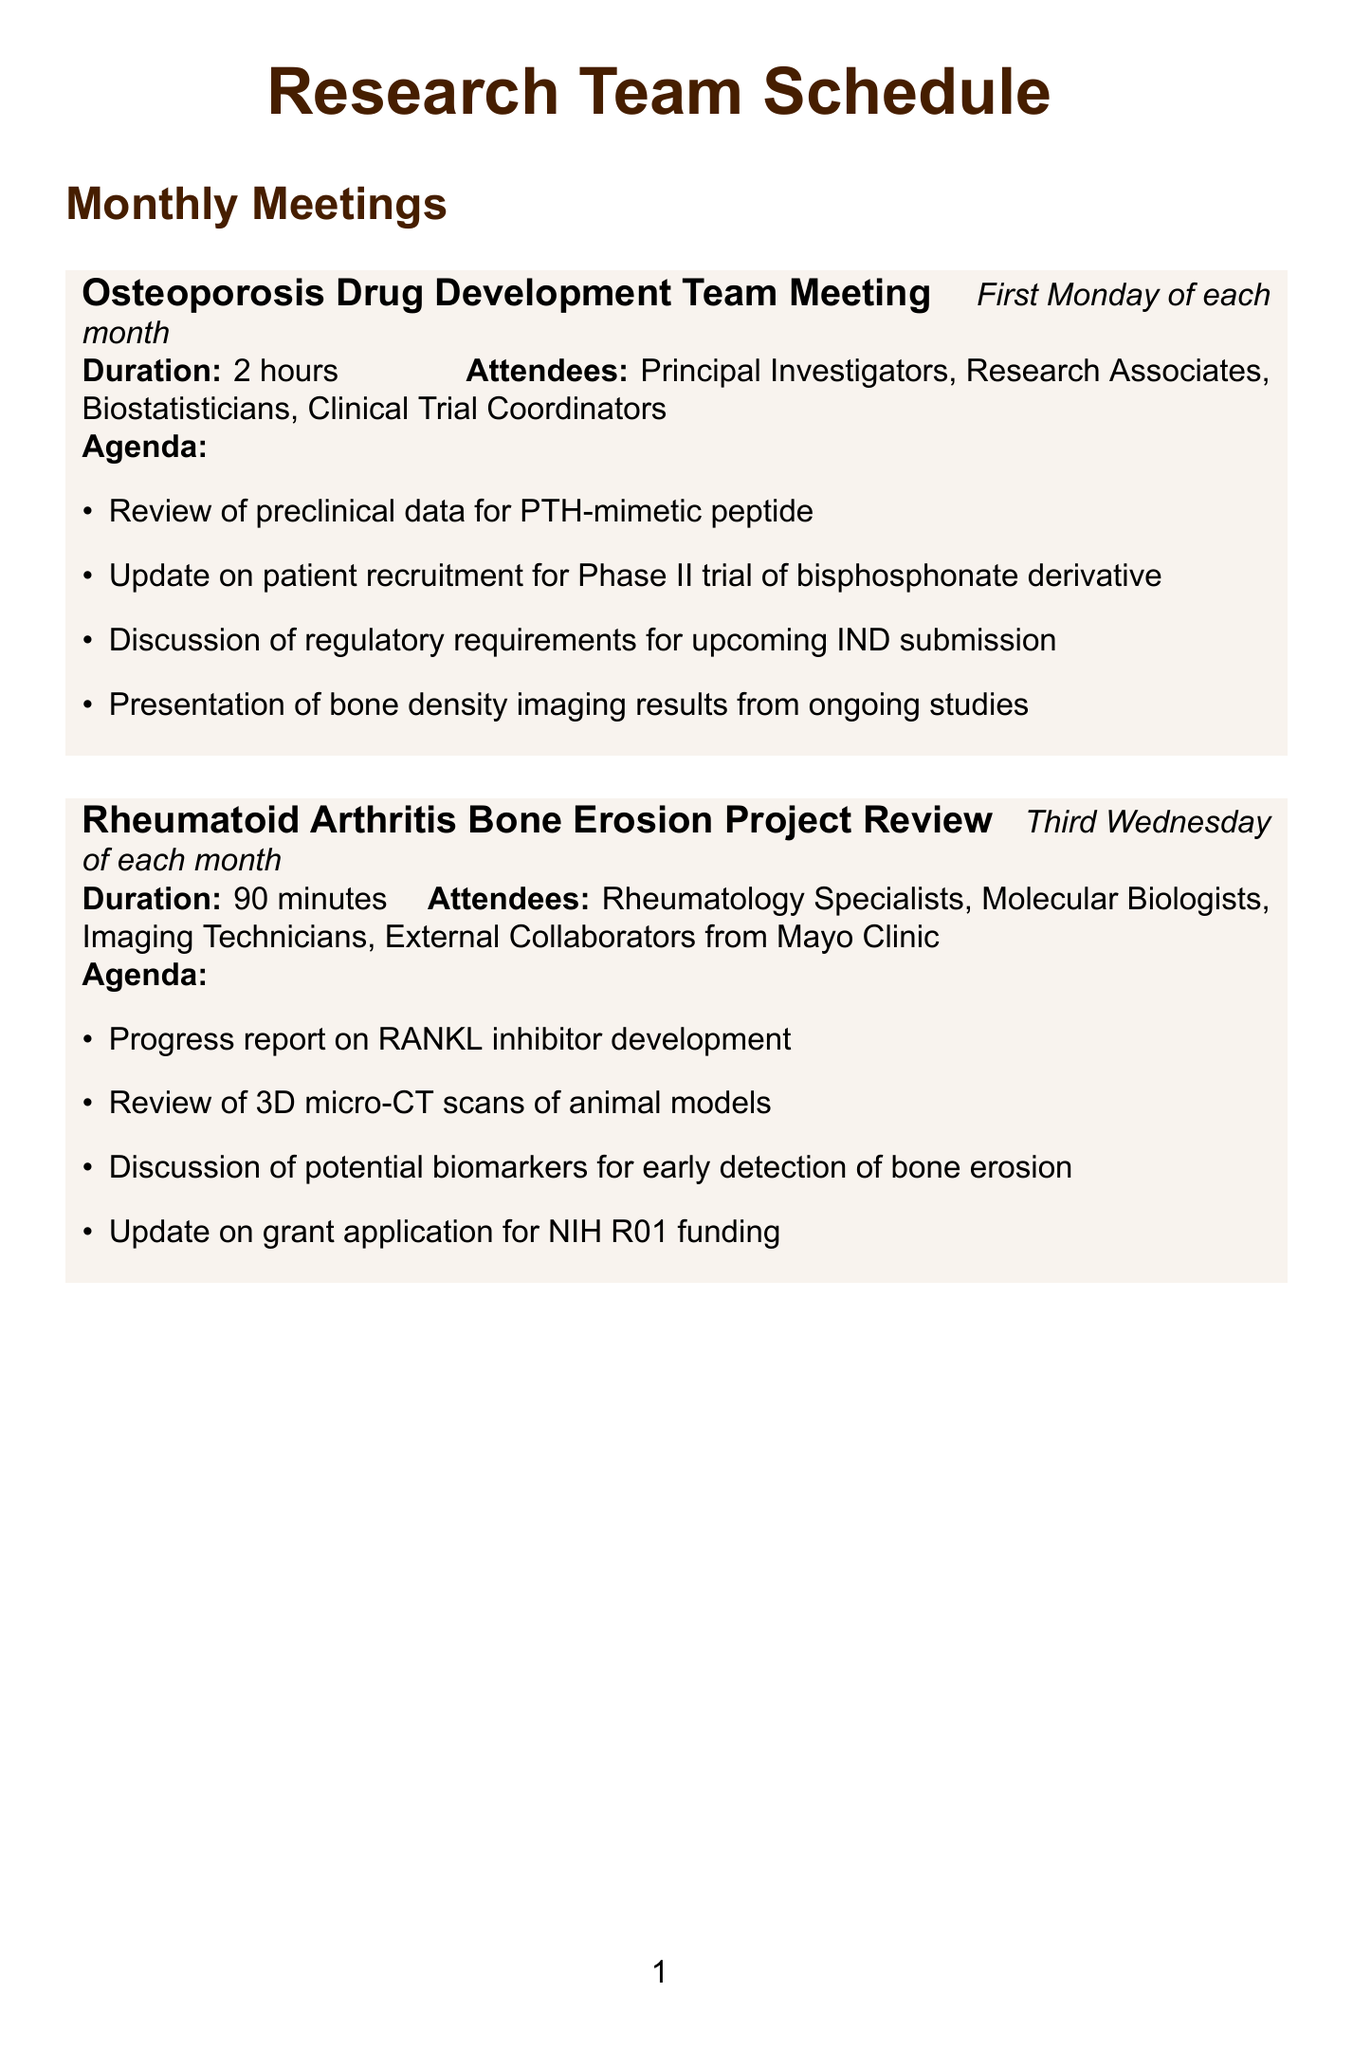what is the duration of the Osteoporosis Drug Development Team Meeting? The duration is specified as 2 hours in the document.
Answer: 2 hours when do the Rheumatoid Arthritis Bone Erosion Project Review meetings occur? The meetings occur on the third Wednesday of each month as stated in the schedule.
Answer: Third Wednesday of each month who are the attendees of the Quarterly Bone Anabolic Agent Pipeline Review? The attendees listed include Research Directors, Project Managers, Lead Scientists, and Representatives from Amgen and Eli Lilly.
Answer: Research Directors, Project Managers, Lead Scientists, Representatives from Amgen and Eli Lilly what is one of the agenda items for the Biannual Bone Metastasis Research Symposium? The agenda includes a keynote lecture on recent advances in bone metastasis prevention.
Answer: Keynote lecture on recent advances in bone metastasis prevention how often is the FDA Advisory Committee Preparation Meeting scheduled? The meetings are held as needed, typically 4-6 weeks before an FDA meeting.
Answer: As needed, typically 4-6 weeks before FDA meeting how long is the duration of the Bone Tissue Engineering Collaboration Kickoff? The duration of this meeting is specified as 2 hours.
Answer: 2 hours what is the focus of the update provided in the Osteoporosis Drug Development Team Meeting? The update focuses on patient recruitment for the Phase II trial of a bisphosphonate derivative.
Answer: Patient recruitment for Phase II trial of bisphosphonate derivative how many agenda items are listed for the Rheumatoid Arthritis Bone Erosion Project Review? There are four agenda items listed for this meeting.
Answer: 4 what type of specialists attend the Biannual Bone Metastasis Research Symposium? The attendees include Oncologists, Bone Biology Researchers, Radiologists, and Representatives from MD Anderson Cancer Center.
Answer: Oncologists, Bone Biology Researchers, Radiologists, Representatives from MD Anderson Cancer Center 